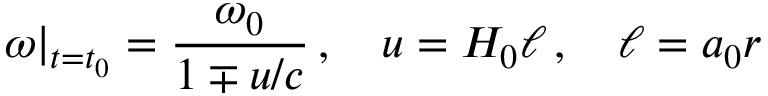Convert formula to latex. <formula><loc_0><loc_0><loc_500><loc_500>\omega \right | _ { t = t _ { 0 } } = \frac { \omega _ { 0 } } { 1 \mp u / c } \, , \quad u = H _ { 0 } \ell \, , \quad \ell = a _ { 0 } r</formula> 